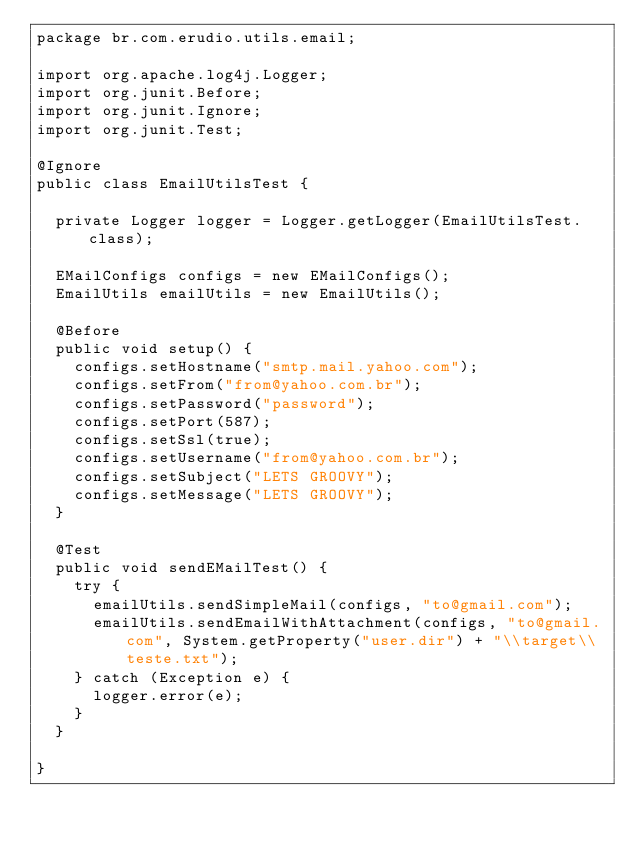Convert code to text. <code><loc_0><loc_0><loc_500><loc_500><_Java_>package br.com.erudio.utils.email;

import org.apache.log4j.Logger;
import org.junit.Before;
import org.junit.Ignore;
import org.junit.Test;

@Ignore
public class EmailUtilsTest {
	
	private Logger logger = Logger.getLogger(EmailUtilsTest.class);
	
	EMailConfigs configs = new EMailConfigs();
	EmailUtils emailUtils = new EmailUtils();
	
	@Before
	public void setup() {
		configs.setHostname("smtp.mail.yahoo.com");
		configs.setFrom("from@yahoo.com.br");
		configs.setPassword("password");
		configs.setPort(587);
		configs.setSsl(true);
		configs.setUsername("from@yahoo.com.br");
		configs.setSubject("LETS GROOVY");
		configs.setMessage("LETS GROOVY");
	}
	
	@Test
	public void sendEMailTest() {
		try {
			emailUtils.sendSimpleMail(configs, "to@gmail.com");
			emailUtils.sendEmailWithAttachment(configs, "to@gmail.com", System.getProperty("user.dir") + "\\target\\teste.txt");
		} catch (Exception e) {
			logger.error(e);
		}
	}

}
</code> 